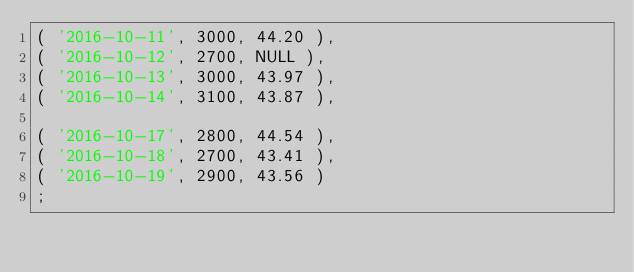<code> <loc_0><loc_0><loc_500><loc_500><_SQL_>( '2016-10-11', 3000, 44.20 ),
( '2016-10-12', 2700, NULL ),
( '2016-10-13', 3000, 43.97 ),
( '2016-10-14', 3100, 43.87 ),

( '2016-10-17', 2800, 44.54 ),
( '2016-10-18', 2700, 43.41 ),
( '2016-10-19', 2900, 43.56 )
;
</code> 